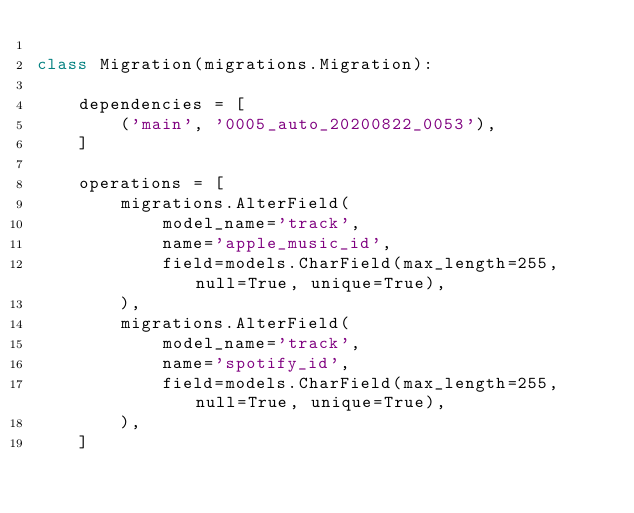<code> <loc_0><loc_0><loc_500><loc_500><_Python_>
class Migration(migrations.Migration):

    dependencies = [
        ('main', '0005_auto_20200822_0053'),
    ]

    operations = [
        migrations.AlterField(
            model_name='track',
            name='apple_music_id',
            field=models.CharField(max_length=255, null=True, unique=True),
        ),
        migrations.AlterField(
            model_name='track',
            name='spotify_id',
            field=models.CharField(max_length=255, null=True, unique=True),
        ),
    ]
</code> 